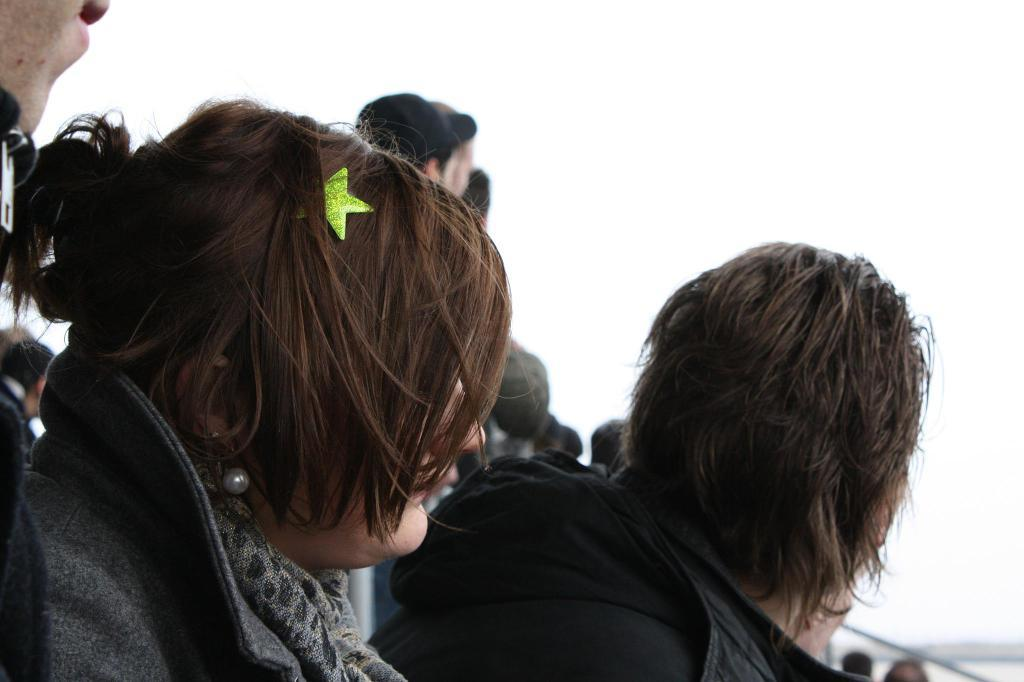What are the people in the image doing? The people in the image are sitting and standing. What can be seen in the background of the image? The sky is visible in the background of the image. How much money does the beggar have in the image? There is no beggar present in the image, so it is not possible to determine how much money they might have. 